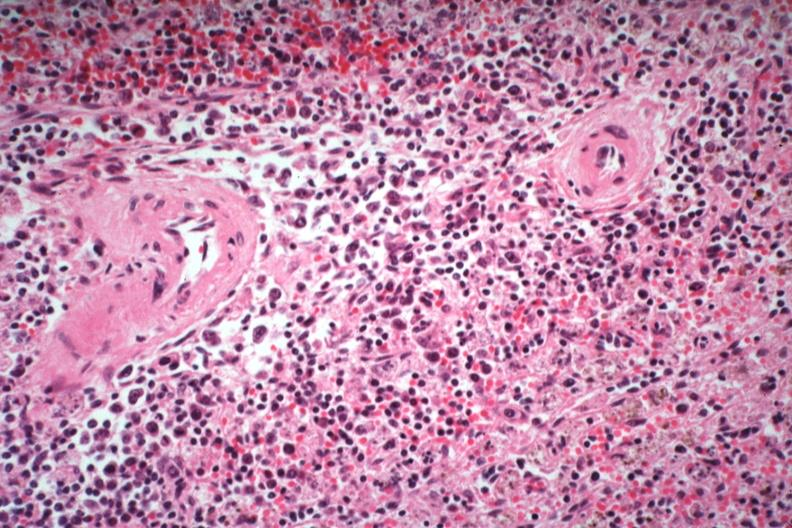what is immunoblastic type cells near splenic arteriole man died?
Answer the question using a single word or phrase. Of what was thought to be viral pneumonia probably influenza 